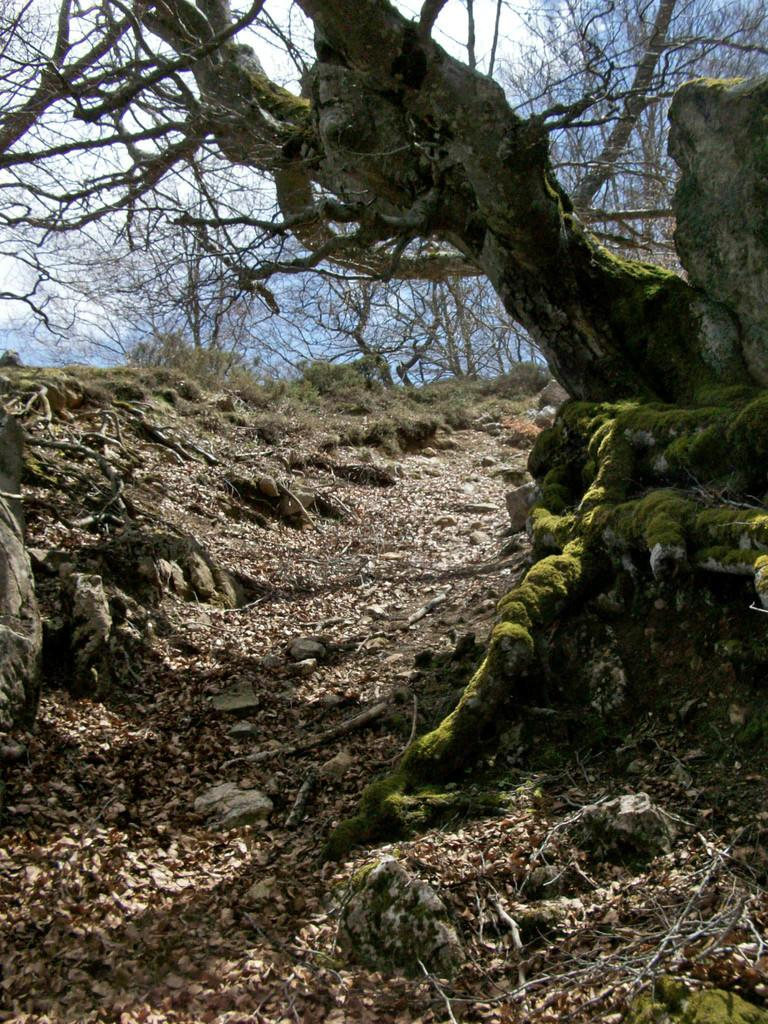What can be found at the bottom of the image? Dried leaves and twigs are present at the bottom of the image. What is located on the right side of the image? There is a tree on the right side of the image. What can be seen in the distance in the image? There are trees visible in the background of the image. What knowledge can be gained from the drain in the image? There is no drain present in the image, so no knowledge can be gained from it. 